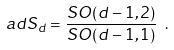<formula> <loc_0><loc_0><loc_500><loc_500>a d S _ { d } = \frac { S O ( d - 1 , 2 ) } { S O ( d - 1 , 1 ) } \ .</formula> 